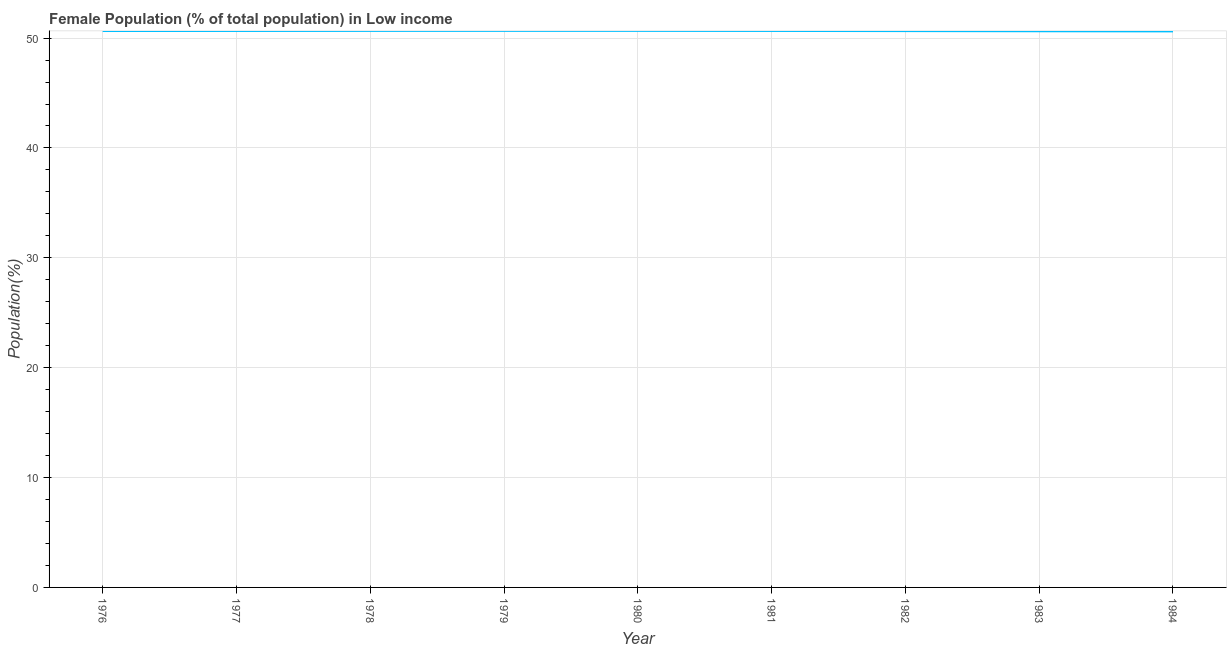What is the female population in 1984?
Your response must be concise. 50.61. Across all years, what is the maximum female population?
Your answer should be compact. 50.66. Across all years, what is the minimum female population?
Your response must be concise. 50.61. In which year was the female population maximum?
Make the answer very short. 1979. In which year was the female population minimum?
Give a very brief answer. 1984. What is the sum of the female population?
Your answer should be very brief. 455.78. What is the difference between the female population in 1976 and 1982?
Provide a succinct answer. 0.01. What is the average female population per year?
Give a very brief answer. 50.64. What is the median female population?
Your answer should be very brief. 50.65. Do a majority of the years between 1982 and 1983 (inclusive) have female population greater than 26 %?
Your answer should be compact. Yes. What is the ratio of the female population in 1980 to that in 1983?
Provide a short and direct response. 1. Is the female population in 1977 less than that in 1981?
Offer a very short reply. Yes. What is the difference between the highest and the second highest female population?
Your response must be concise. 0. What is the difference between the highest and the lowest female population?
Ensure brevity in your answer.  0.05. How many years are there in the graph?
Your answer should be very brief. 9. What is the difference between two consecutive major ticks on the Y-axis?
Your answer should be very brief. 10. What is the title of the graph?
Ensure brevity in your answer.  Female Population (% of total population) in Low income. What is the label or title of the X-axis?
Make the answer very short. Year. What is the label or title of the Y-axis?
Keep it short and to the point. Population(%). What is the Population(%) in 1976?
Keep it short and to the point. 50.64. What is the Population(%) of 1977?
Your response must be concise. 50.65. What is the Population(%) in 1978?
Your answer should be very brief. 50.65. What is the Population(%) in 1979?
Provide a short and direct response. 50.66. What is the Population(%) of 1980?
Provide a short and direct response. 50.66. What is the Population(%) in 1981?
Provide a short and direct response. 50.65. What is the Population(%) in 1982?
Your answer should be very brief. 50.64. What is the Population(%) of 1983?
Give a very brief answer. 50.62. What is the Population(%) in 1984?
Offer a terse response. 50.61. What is the difference between the Population(%) in 1976 and 1977?
Ensure brevity in your answer.  -0.01. What is the difference between the Population(%) in 1976 and 1978?
Make the answer very short. -0.01. What is the difference between the Population(%) in 1976 and 1979?
Your answer should be compact. -0.02. What is the difference between the Population(%) in 1976 and 1980?
Make the answer very short. -0.01. What is the difference between the Population(%) in 1976 and 1981?
Keep it short and to the point. -0.01. What is the difference between the Population(%) in 1976 and 1982?
Your answer should be very brief. 0.01. What is the difference between the Population(%) in 1976 and 1983?
Ensure brevity in your answer.  0.02. What is the difference between the Population(%) in 1976 and 1984?
Provide a succinct answer. 0.03. What is the difference between the Population(%) in 1977 and 1978?
Your response must be concise. -0.01. What is the difference between the Population(%) in 1977 and 1979?
Keep it short and to the point. -0.01. What is the difference between the Population(%) in 1977 and 1980?
Keep it short and to the point. -0.01. What is the difference between the Population(%) in 1977 and 1981?
Your answer should be compact. -0. What is the difference between the Population(%) in 1977 and 1982?
Make the answer very short. 0.01. What is the difference between the Population(%) in 1977 and 1983?
Keep it short and to the point. 0.03. What is the difference between the Population(%) in 1977 and 1984?
Offer a very short reply. 0.04. What is the difference between the Population(%) in 1978 and 1979?
Give a very brief answer. -0. What is the difference between the Population(%) in 1978 and 1980?
Your answer should be compact. -0. What is the difference between the Population(%) in 1978 and 1981?
Offer a terse response. 0.01. What is the difference between the Population(%) in 1978 and 1982?
Offer a very short reply. 0.02. What is the difference between the Population(%) in 1978 and 1983?
Your response must be concise. 0.03. What is the difference between the Population(%) in 1978 and 1984?
Offer a very short reply. 0.05. What is the difference between the Population(%) in 1979 and 1980?
Ensure brevity in your answer.  0. What is the difference between the Population(%) in 1979 and 1981?
Ensure brevity in your answer.  0.01. What is the difference between the Population(%) in 1979 and 1982?
Give a very brief answer. 0.02. What is the difference between the Population(%) in 1979 and 1983?
Provide a succinct answer. 0.04. What is the difference between the Population(%) in 1979 and 1984?
Your answer should be compact. 0.05. What is the difference between the Population(%) in 1980 and 1981?
Make the answer very short. 0.01. What is the difference between the Population(%) in 1980 and 1982?
Offer a very short reply. 0.02. What is the difference between the Population(%) in 1980 and 1983?
Provide a succinct answer. 0.04. What is the difference between the Population(%) in 1980 and 1984?
Make the answer very short. 0.05. What is the difference between the Population(%) in 1981 and 1982?
Your answer should be compact. 0.01. What is the difference between the Population(%) in 1981 and 1983?
Give a very brief answer. 0.03. What is the difference between the Population(%) in 1981 and 1984?
Offer a terse response. 0.04. What is the difference between the Population(%) in 1982 and 1983?
Keep it short and to the point. 0.01. What is the difference between the Population(%) in 1982 and 1984?
Give a very brief answer. 0.03. What is the difference between the Population(%) in 1983 and 1984?
Provide a short and direct response. 0.01. What is the ratio of the Population(%) in 1976 to that in 1978?
Your answer should be compact. 1. What is the ratio of the Population(%) in 1976 to that in 1979?
Offer a very short reply. 1. What is the ratio of the Population(%) in 1976 to that in 1980?
Offer a very short reply. 1. What is the ratio of the Population(%) in 1976 to that in 1982?
Make the answer very short. 1. What is the ratio of the Population(%) in 1976 to that in 1984?
Keep it short and to the point. 1. What is the ratio of the Population(%) in 1977 to that in 1978?
Your answer should be very brief. 1. What is the ratio of the Population(%) in 1977 to that in 1980?
Make the answer very short. 1. What is the ratio of the Population(%) in 1977 to that in 1981?
Offer a very short reply. 1. What is the ratio of the Population(%) in 1977 to that in 1982?
Provide a short and direct response. 1. What is the ratio of the Population(%) in 1977 to that in 1984?
Make the answer very short. 1. What is the ratio of the Population(%) in 1978 to that in 1979?
Your response must be concise. 1. What is the ratio of the Population(%) in 1978 to that in 1980?
Your response must be concise. 1. What is the ratio of the Population(%) in 1978 to that in 1981?
Your answer should be compact. 1. What is the ratio of the Population(%) in 1978 to that in 1982?
Give a very brief answer. 1. What is the ratio of the Population(%) in 1979 to that in 1983?
Provide a short and direct response. 1. What is the ratio of the Population(%) in 1982 to that in 1983?
Your response must be concise. 1. 